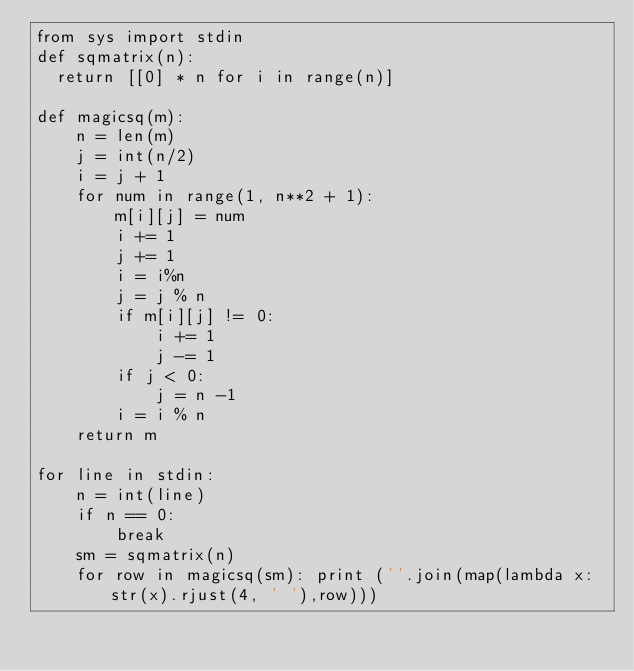<code> <loc_0><loc_0><loc_500><loc_500><_Python_>from sys import stdin
def sqmatrix(n):
  return [[0] * n for i in range(n)]

def magicsq(m):
    n = len(m)
    j = int(n/2)
    i = j + 1
    for num in range(1, n**2 + 1):
        m[i][j] = num
        i += 1
        j += 1
        i = i%n
        j = j % n
        if m[i][j] != 0:
            i += 1
            j -= 1
        if j < 0:
            j = n -1
        i = i % n
    return m

for line in stdin:
    n = int(line)
    if n == 0:
        break
    sm = sqmatrix(n)
    for row in magicsq(sm): print (''.join(map(lambda x: str(x).rjust(4, ' '),row)))</code> 